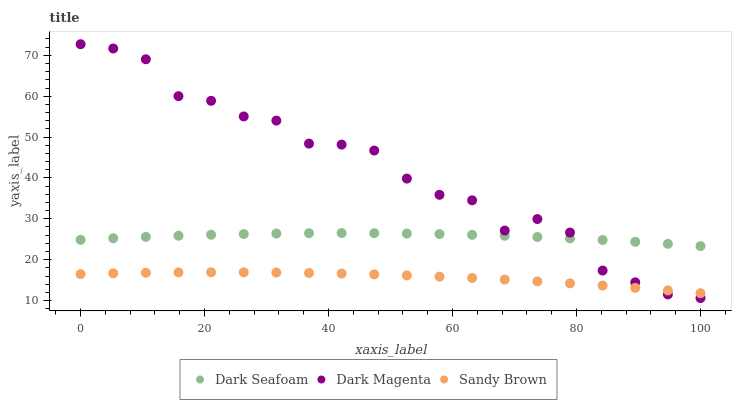Does Sandy Brown have the minimum area under the curve?
Answer yes or no. Yes. Does Dark Magenta have the maximum area under the curve?
Answer yes or no. Yes. Does Dark Magenta have the minimum area under the curve?
Answer yes or no. No. Does Sandy Brown have the maximum area under the curve?
Answer yes or no. No. Is Sandy Brown the smoothest?
Answer yes or no. Yes. Is Dark Magenta the roughest?
Answer yes or no. Yes. Is Dark Magenta the smoothest?
Answer yes or no. No. Is Sandy Brown the roughest?
Answer yes or no. No. Does Dark Magenta have the lowest value?
Answer yes or no. Yes. Does Sandy Brown have the lowest value?
Answer yes or no. No. Does Dark Magenta have the highest value?
Answer yes or no. Yes. Does Sandy Brown have the highest value?
Answer yes or no. No. Is Sandy Brown less than Dark Seafoam?
Answer yes or no. Yes. Is Dark Seafoam greater than Sandy Brown?
Answer yes or no. Yes. Does Dark Seafoam intersect Dark Magenta?
Answer yes or no. Yes. Is Dark Seafoam less than Dark Magenta?
Answer yes or no. No. Is Dark Seafoam greater than Dark Magenta?
Answer yes or no. No. Does Sandy Brown intersect Dark Seafoam?
Answer yes or no. No. 